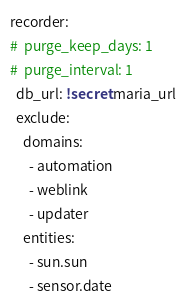Convert code to text. <code><loc_0><loc_0><loc_500><loc_500><_YAML_>recorder:
#  purge_keep_days: 1
#  purge_interval: 1
  db_url: !secret maria_url
  exclude:
    domains:
      - automation
      - weblink
      - updater
    entities:
      - sun.sun
      - sensor.date
</code> 